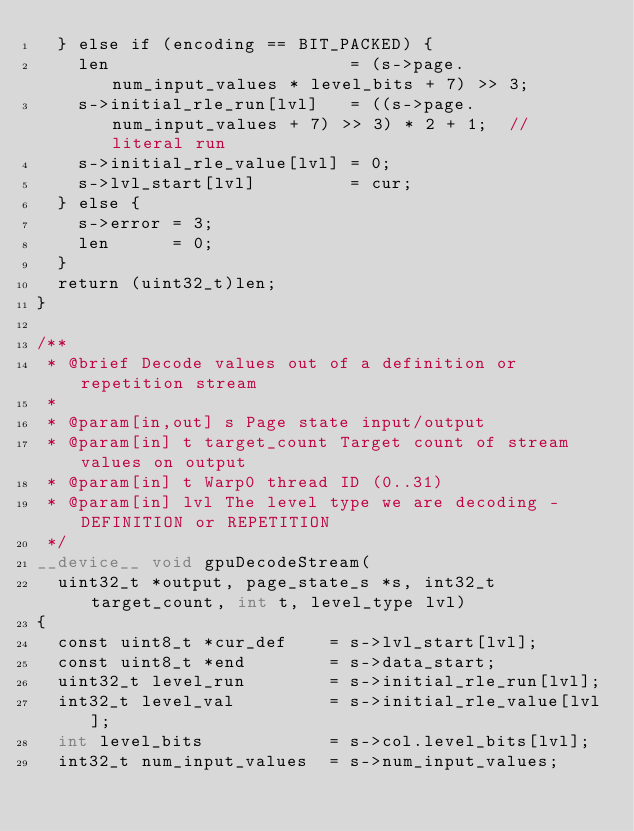Convert code to text. <code><loc_0><loc_0><loc_500><loc_500><_Cuda_>  } else if (encoding == BIT_PACKED) {
    len                       = (s->page.num_input_values * level_bits + 7) >> 3;
    s->initial_rle_run[lvl]   = ((s->page.num_input_values + 7) >> 3) * 2 + 1;  // literal run
    s->initial_rle_value[lvl] = 0;
    s->lvl_start[lvl]         = cur;
  } else {
    s->error = 3;
    len      = 0;
  }
  return (uint32_t)len;
}

/**
 * @brief Decode values out of a definition or repetition stream
 *
 * @param[in,out] s Page state input/output
 * @param[in] t target_count Target count of stream values on output
 * @param[in] t Warp0 thread ID (0..31)
 * @param[in] lvl The level type we are decoding - DEFINITION or REPETITION
 */
__device__ void gpuDecodeStream(
  uint32_t *output, page_state_s *s, int32_t target_count, int t, level_type lvl)
{
  const uint8_t *cur_def    = s->lvl_start[lvl];
  const uint8_t *end        = s->data_start;
  uint32_t level_run        = s->initial_rle_run[lvl];
  int32_t level_val         = s->initial_rle_value[lvl];
  int level_bits            = s->col.level_bits[lvl];
  int32_t num_input_values  = s->num_input_values;</code> 